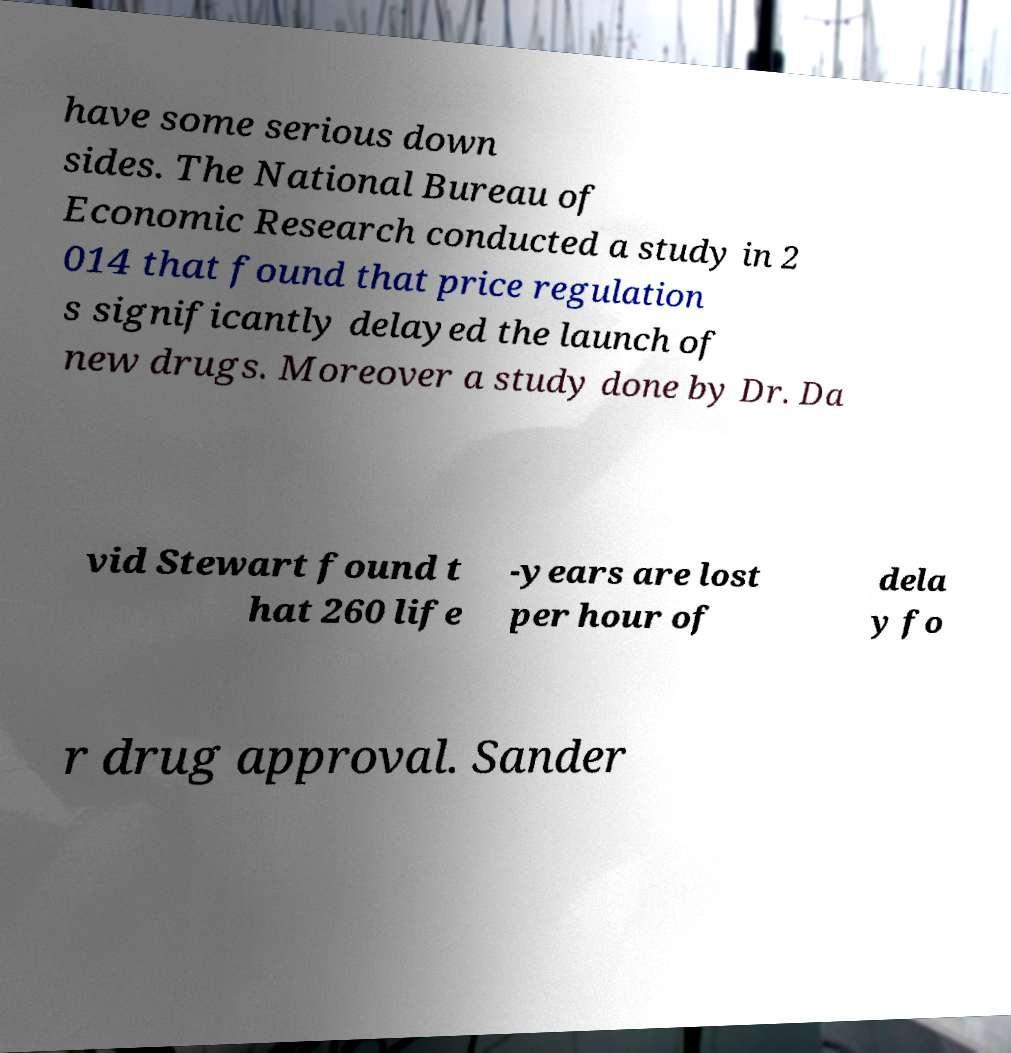Can you read and provide the text displayed in the image?This photo seems to have some interesting text. Can you extract and type it out for me? have some serious down sides. The National Bureau of Economic Research conducted a study in 2 014 that found that price regulation s significantly delayed the launch of new drugs. Moreover a study done by Dr. Da vid Stewart found t hat 260 life -years are lost per hour of dela y fo r drug approval. Sander 